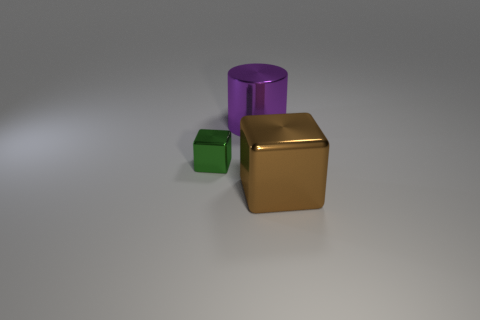Subtract all green cubes. How many cubes are left? 1 Subtract 1 blocks. How many blocks are left? 1 Add 1 big things. How many objects exist? 4 Add 3 rubber objects. How many rubber objects exist? 3 Subtract 1 brown blocks. How many objects are left? 2 Subtract all cubes. How many objects are left? 1 Subtract all red blocks. Subtract all blue cylinders. How many blocks are left? 2 Subtract all gray cylinders. How many green blocks are left? 1 Subtract all big brown matte cylinders. Subtract all large brown things. How many objects are left? 2 Add 1 brown objects. How many brown objects are left? 2 